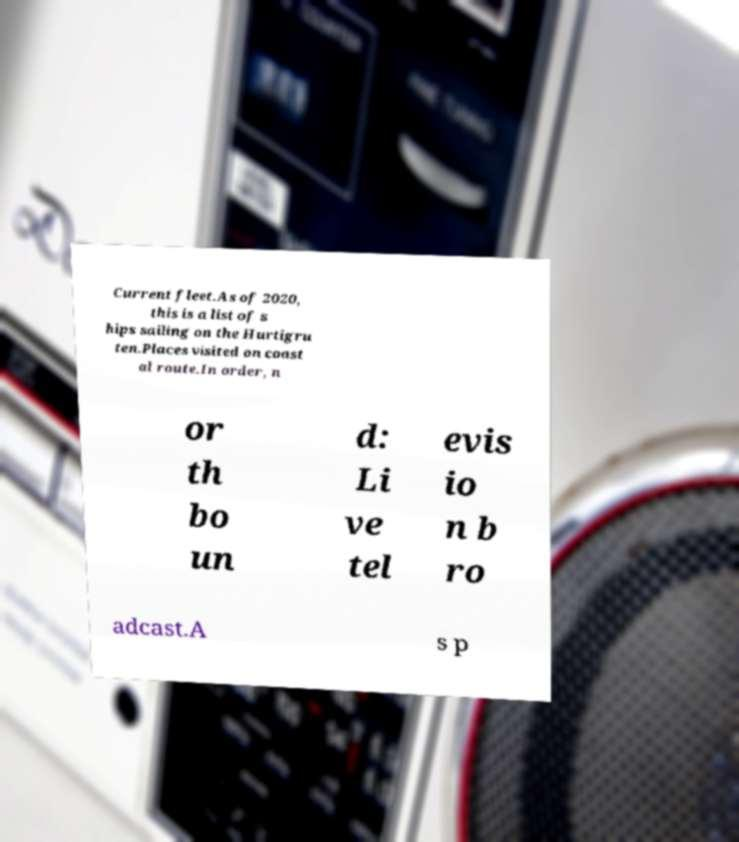Please identify and transcribe the text found in this image. Current fleet.As of 2020, this is a list of s hips sailing on the Hurtigru ten.Places visited on coast al route.In order, n or th bo un d: Li ve tel evis io n b ro adcast.A s p 